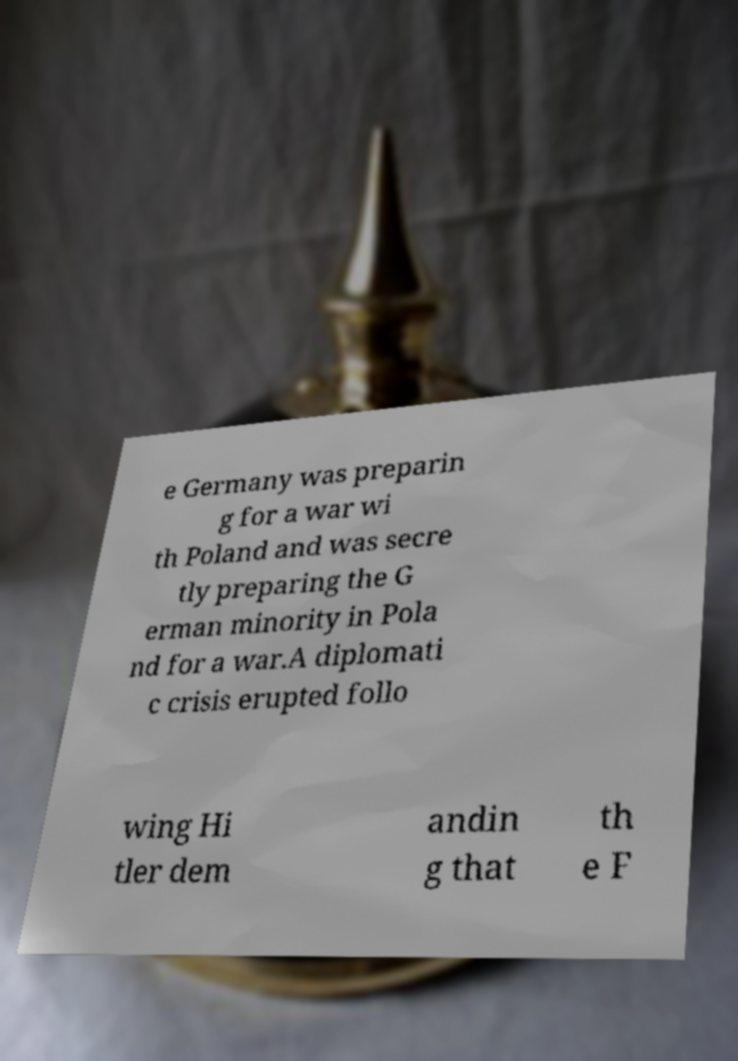I need the written content from this picture converted into text. Can you do that? e Germany was preparin g for a war wi th Poland and was secre tly preparing the G erman minority in Pola nd for a war.A diplomati c crisis erupted follo wing Hi tler dem andin g that th e F 